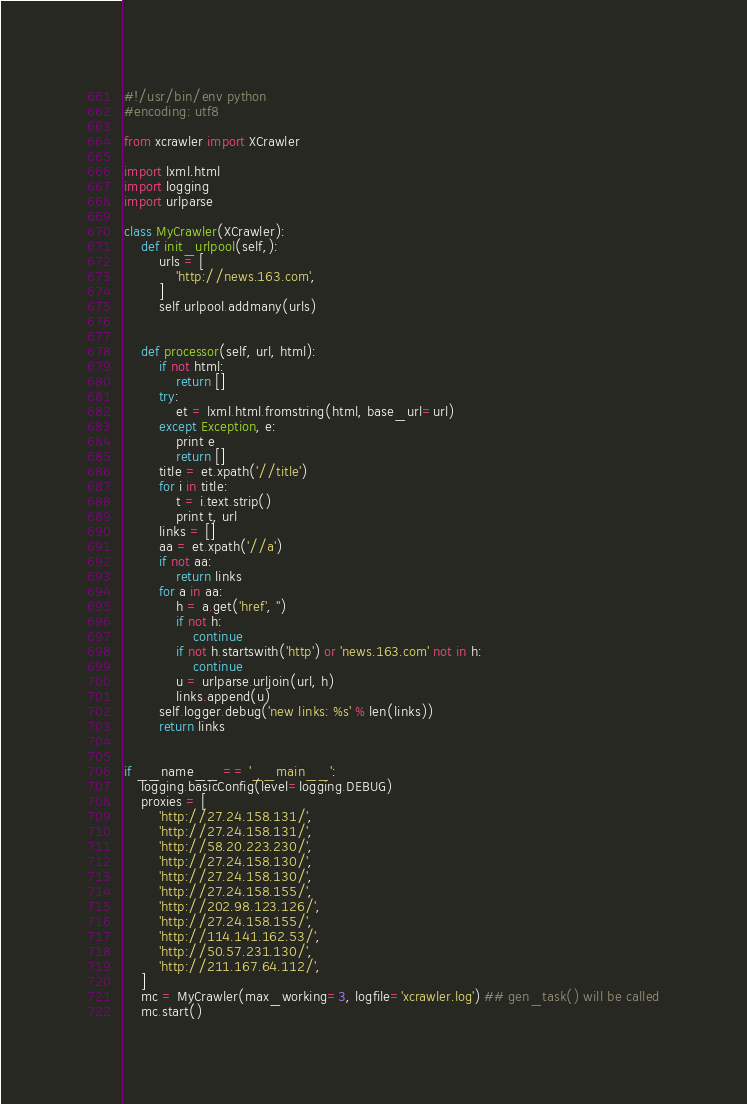Convert code to text. <code><loc_0><loc_0><loc_500><loc_500><_Python_>#!/usr/bin/env python
#encoding: utf8

from xcrawler import XCrawler

import lxml.html
import logging
import urlparse

class MyCrawler(XCrawler):
    def init_urlpool(self,):
        urls = [
            'http://news.163.com',
        ]
        self.urlpool.addmany(urls)


    def processor(self, url, html):
        if not html:
            return []
        try:
            et = lxml.html.fromstring(html, base_url=url)
        except Exception, e:
            print e
            return []
        title = et.xpath('//title')
        for i in title:
            t = i.text.strip()
            print t, url
        links = []
        aa = et.xpath('//a')
        if not aa:
            return links
        for a in aa:
            h = a.get('href', '')
            if not h:
                continue
            if not h.startswith('http') or 'news.163.com' not in h:
                continue
            u = urlparse.urljoin(url, h)
            links.append(u)
        self.logger.debug('new links: %s' % len(links))
        return links


if __name__ == '__main__':
    logging.basicConfig(level=logging.DEBUG)
    proxies = [
        'http://27.24.158.131/',
        'http://27.24.158.131/',
        'http://58.20.223.230/',
        'http://27.24.158.130/',
        'http://27.24.158.130/',
        'http://27.24.158.155/',
        'http://202.98.123.126/',
        'http://27.24.158.155/',
        'http://114.141.162.53/',
        'http://50.57.231.130/',
        'http://211.167.64.112/',
    ]
    mc = MyCrawler(max_working=3, logfile='xcrawler.log') ## gen_task() will be called
    mc.start()


</code> 